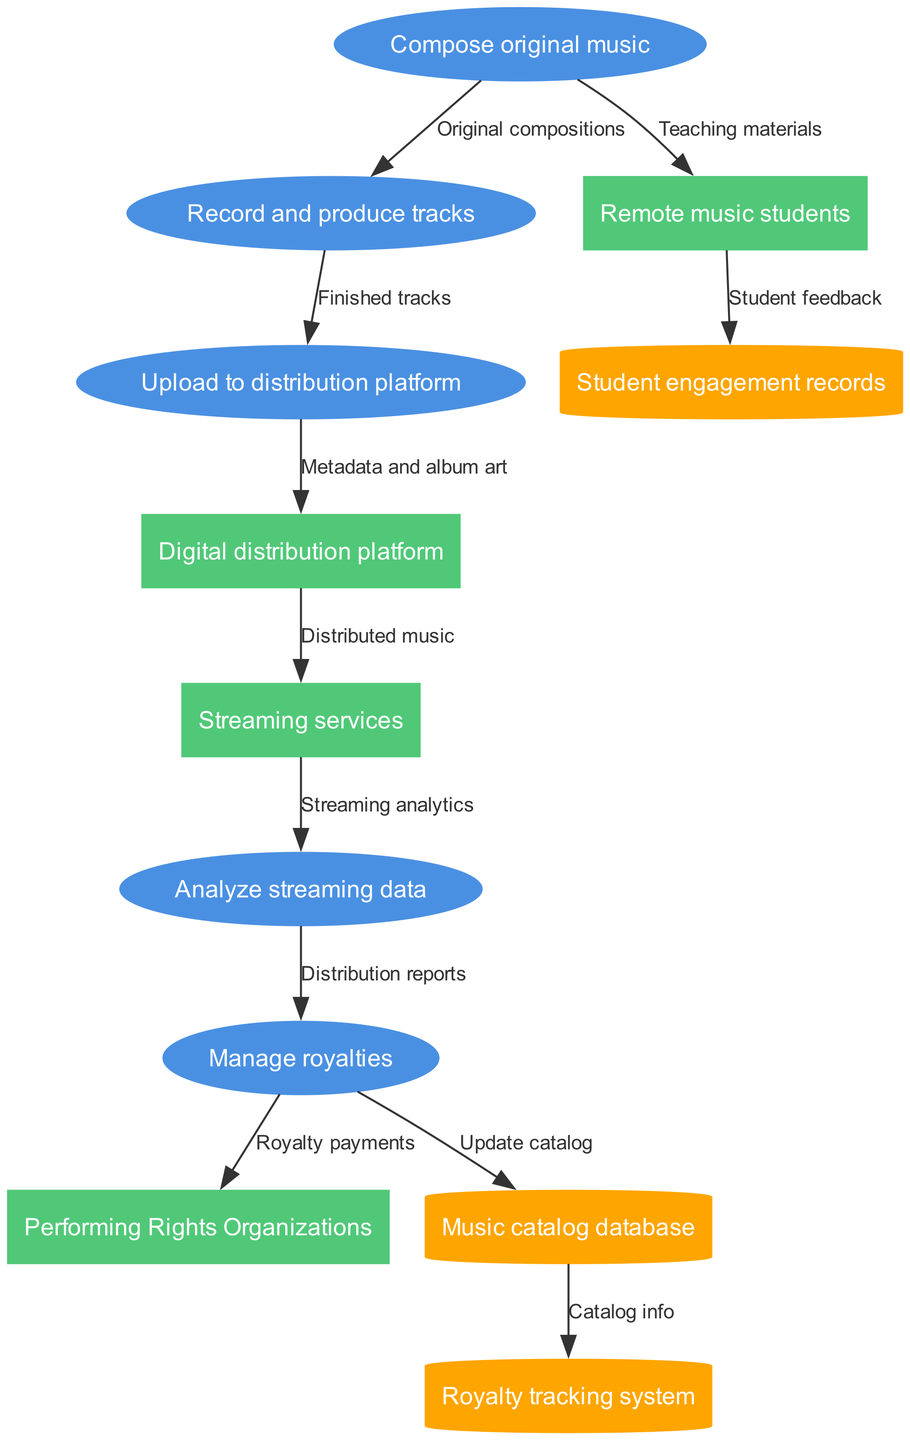What is the first process in the diagram? The first process listed in the diagram is "Compose original music," as it is the starting point of the flow.
Answer: Compose original music How many data stores are included in the diagram? There are three data stores shown in the diagram, which are the "Music catalog database," "Royalty tracking system," and "Student engagement records."
Answer: 3 Which external entity receives royalty payments? The external entity that receives royalty payments is "Performing Rights Organizations," as indicated in the flow from "Manage royalties."
Answer: Performing Rights Organizations What data flow occurs from "Upload to distribution platform"? The data flow that occurs from "Upload to distribution platform" is "Metadata and album art," which represents the information being sent to the "Digital distribution platform."
Answer: Metadata and album art What is the relationship between "Analyze streaming data" and "Manage royalties"? The relationship is that "Analyze streaming data" sends "Distribution reports" to "Manage royalties," indicating that the analysis helps in managing royalties effectively.
Answer: Distribution reports What is stored in the "Royalty tracking system"? The "Royalty tracking system" contains catalog info, which is updated from the "Music catalog database." This represents the collection of royalty-related data.
Answer: Catalog info How does music reach streaming services? Music reaches streaming services through the "Digital distribution platform," which receives finished tracks from "Upload to distribution platform," and then sends it to "Streaming services."
Answer: Digital distribution platform Which group is targeted with teaching materials? The targeted group for teaching materials is "Remote music students," as these materials flow directly from the process "Compose original music."
Answer: Remote music students What data flow is connected to "Student engagement records"? The data flow connected to "Student engagement records" is "Student feedback," which comes from "Remote music students," indicating a direct communication line about their experience.
Answer: Student feedback 